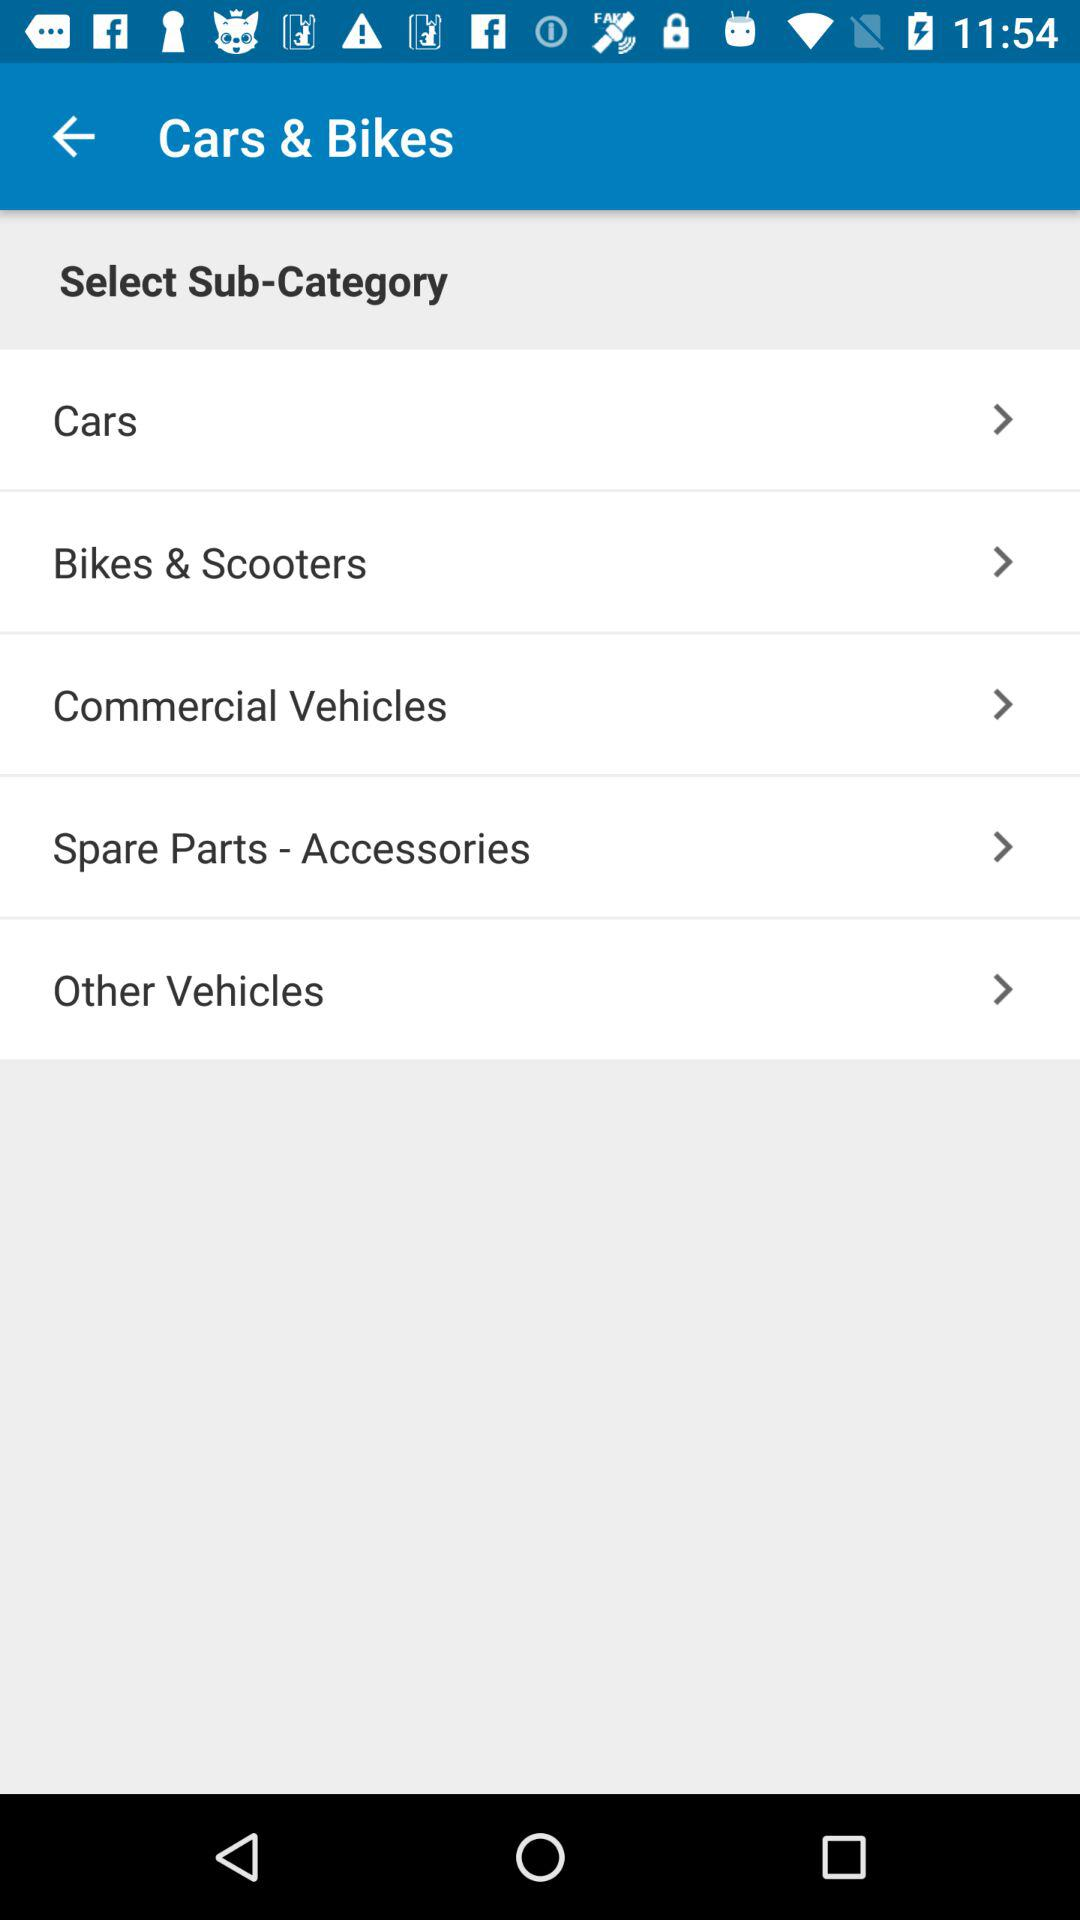How many sub-categories are there in total?
Answer the question using a single word or phrase. 5 